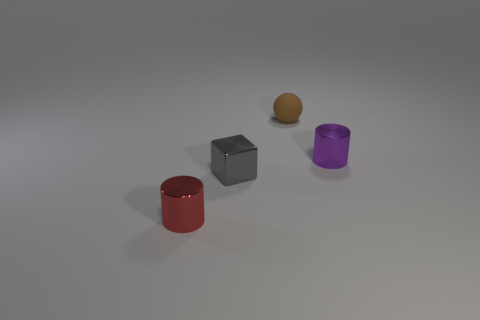Are there any objects in front of the metal cube? Yes, there is a red cylinder positioned in front of the metal cube. 